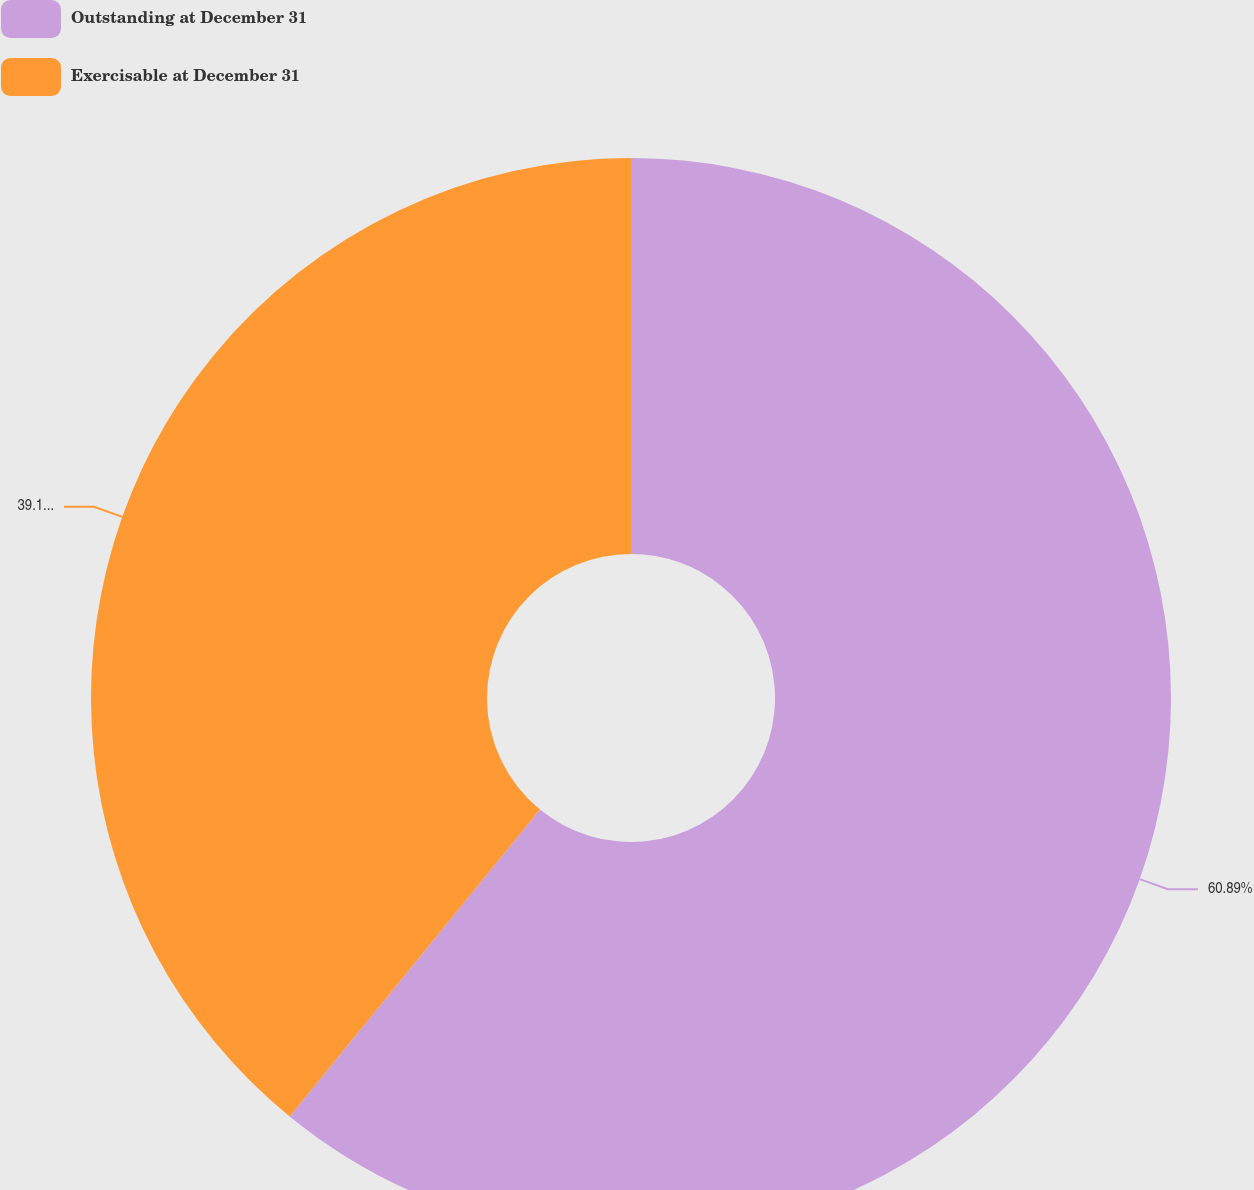Convert chart. <chart><loc_0><loc_0><loc_500><loc_500><pie_chart><fcel>Outstanding at December 31<fcel>Exercisable at December 31<nl><fcel>60.89%<fcel>39.11%<nl></chart> 